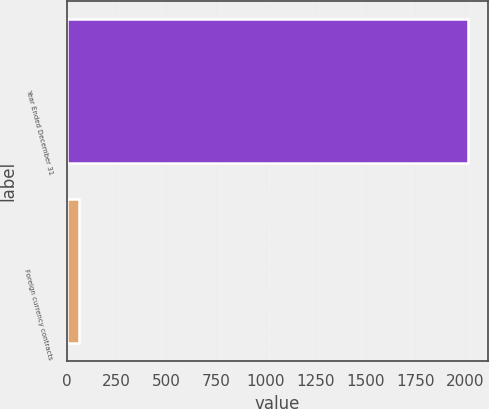Convert chart to OTSL. <chart><loc_0><loc_0><loc_500><loc_500><bar_chart><fcel>Year Ended December 31<fcel>Foreign currency contracts<nl><fcel>2013<fcel>61<nl></chart> 